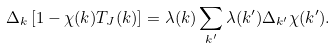<formula> <loc_0><loc_0><loc_500><loc_500>\Delta _ { k } \left [ 1 - \chi ( { k } ) T _ { J } ( { k } ) \right ] = \lambda ( { k } ) \sum _ { k ^ { \prime } } \lambda ( { k } ^ { \prime } ) \Delta _ { { k } ^ { \prime } } \chi ( { k } ^ { \prime } ) .</formula> 